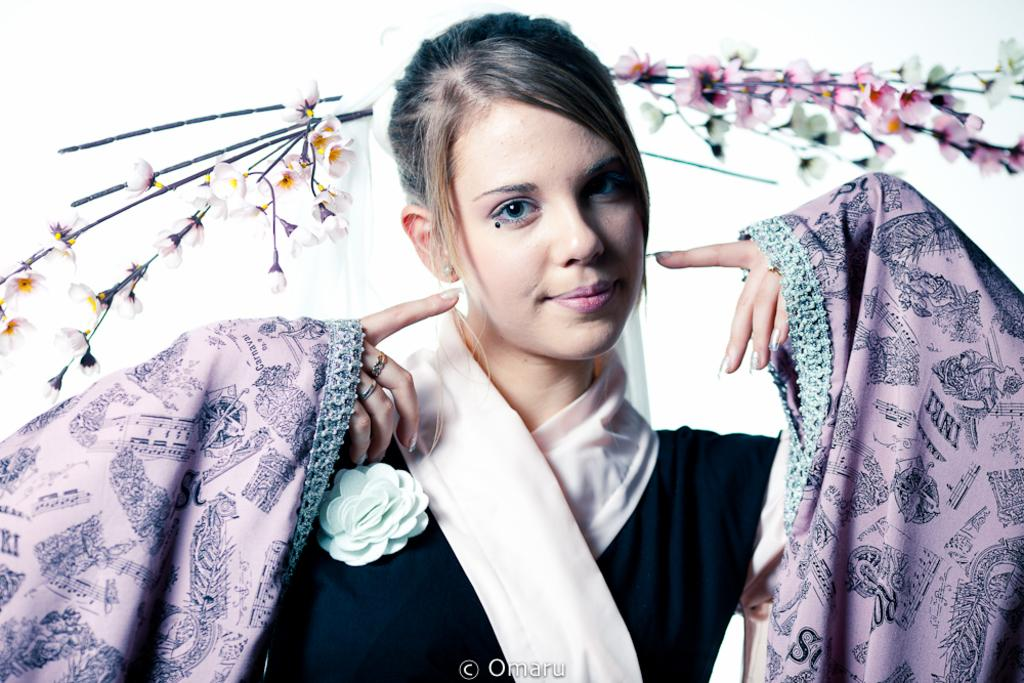What is the main subject of the image? The main subject of the image is a woman. What is the woman wearing in the image? The woman is wearing a dress in the image. What decorative element can be seen in the woman's hair? The woman has flowers in her hair in the image. Can you see any letters or a drawer in the image? There is no mention of letters or a drawer in the provided facts, so we cannot determine their presence in the image. 